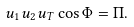<formula> <loc_0><loc_0><loc_500><loc_500>u _ { 1 } u _ { 2 } u _ { T } \cos \Phi = \Pi .</formula> 